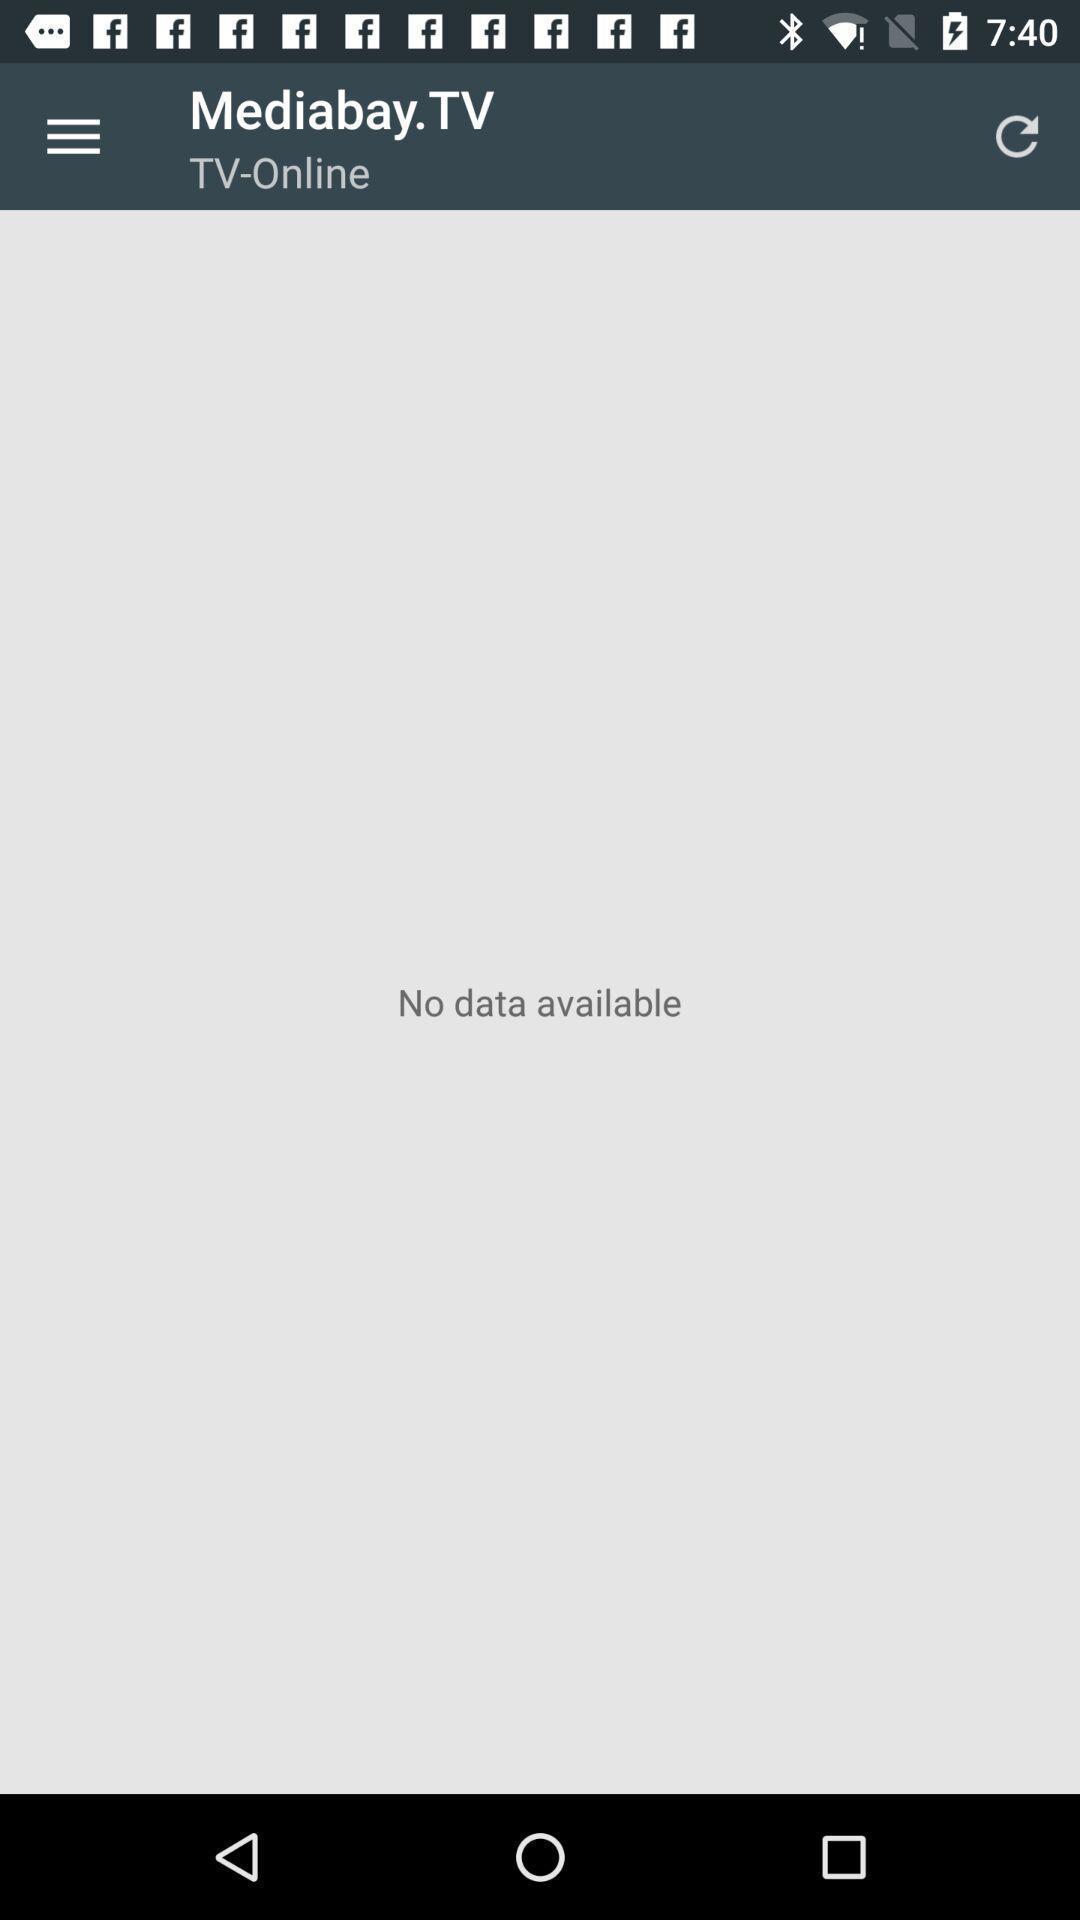Summarize the main components in this picture. Screen showing an entertainment app. 